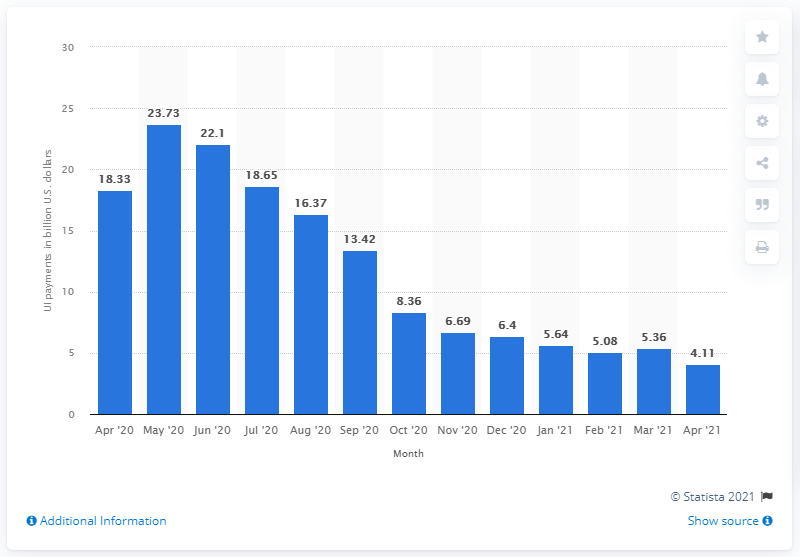Point out several critical features in this image. In April 2021, a total of $4.11 billion in unemployment benefits were paid out. In April 2021, the total amount of unemployment benefits paid out was 18.33 million dollars. 